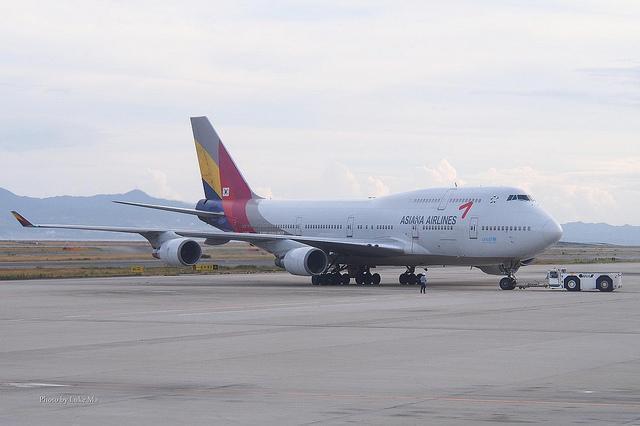This vehicle is most likely from?
Make your selection from the four choices given to correctly answer the question.
Options: Turkey, mexico, afghanistan, south korea. South korea. 